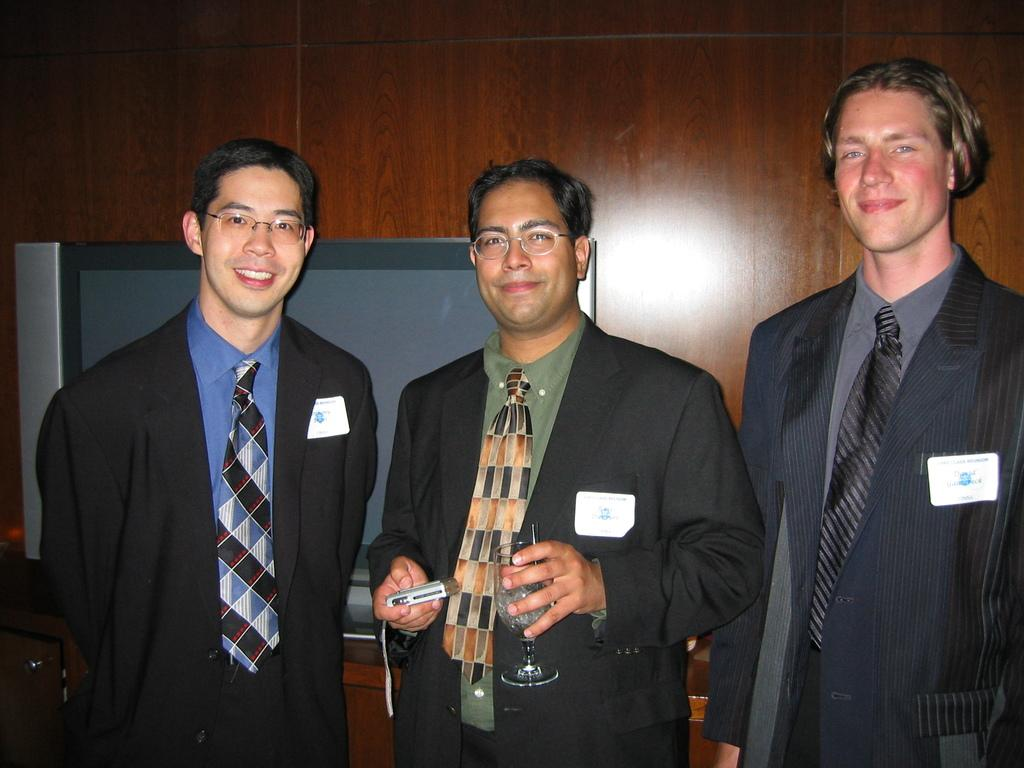How many men are present in the image? There are three men in the image. What are the men holding in the image? One of the men is holding a glass, and another is holding a camera. What can be seen in the background of the image? There is a wooden wall and a TV in the background of the image. What type of insect is crawling on the banana in the image? There is no banana or insect present in the image. 